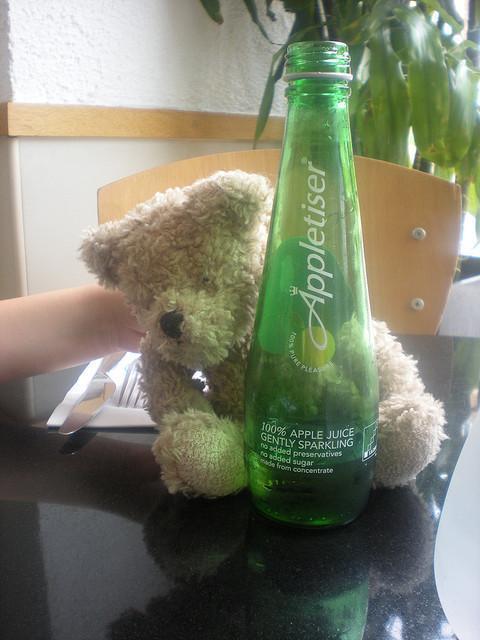What is in the green container?
Choose the right answer and clarify with the format: 'Answer: answer
Rationale: rationale.'
Options: Juice, vinegar, wine, butter. Answer: juice.
Rationale: The bottle says it contains 100% apple juice. 